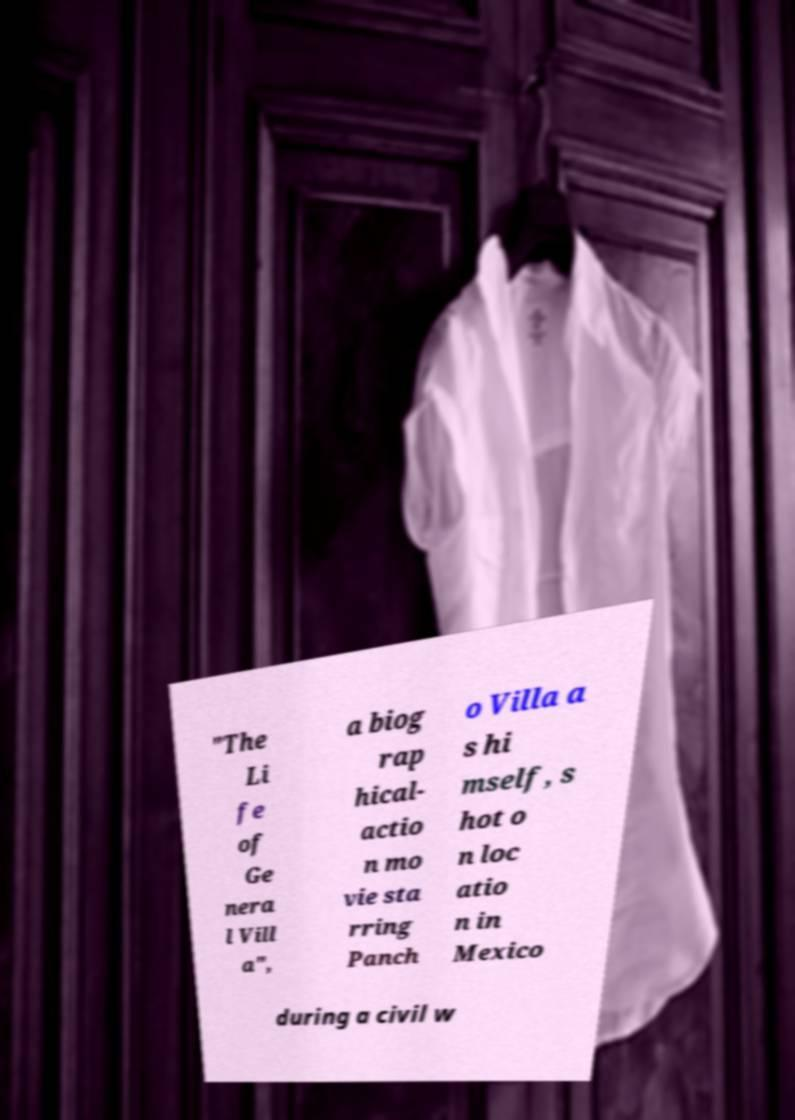Please read and relay the text visible in this image. What does it say? "The Li fe of Ge nera l Vill a", a biog rap hical- actio n mo vie sta rring Panch o Villa a s hi mself, s hot o n loc atio n in Mexico during a civil w 